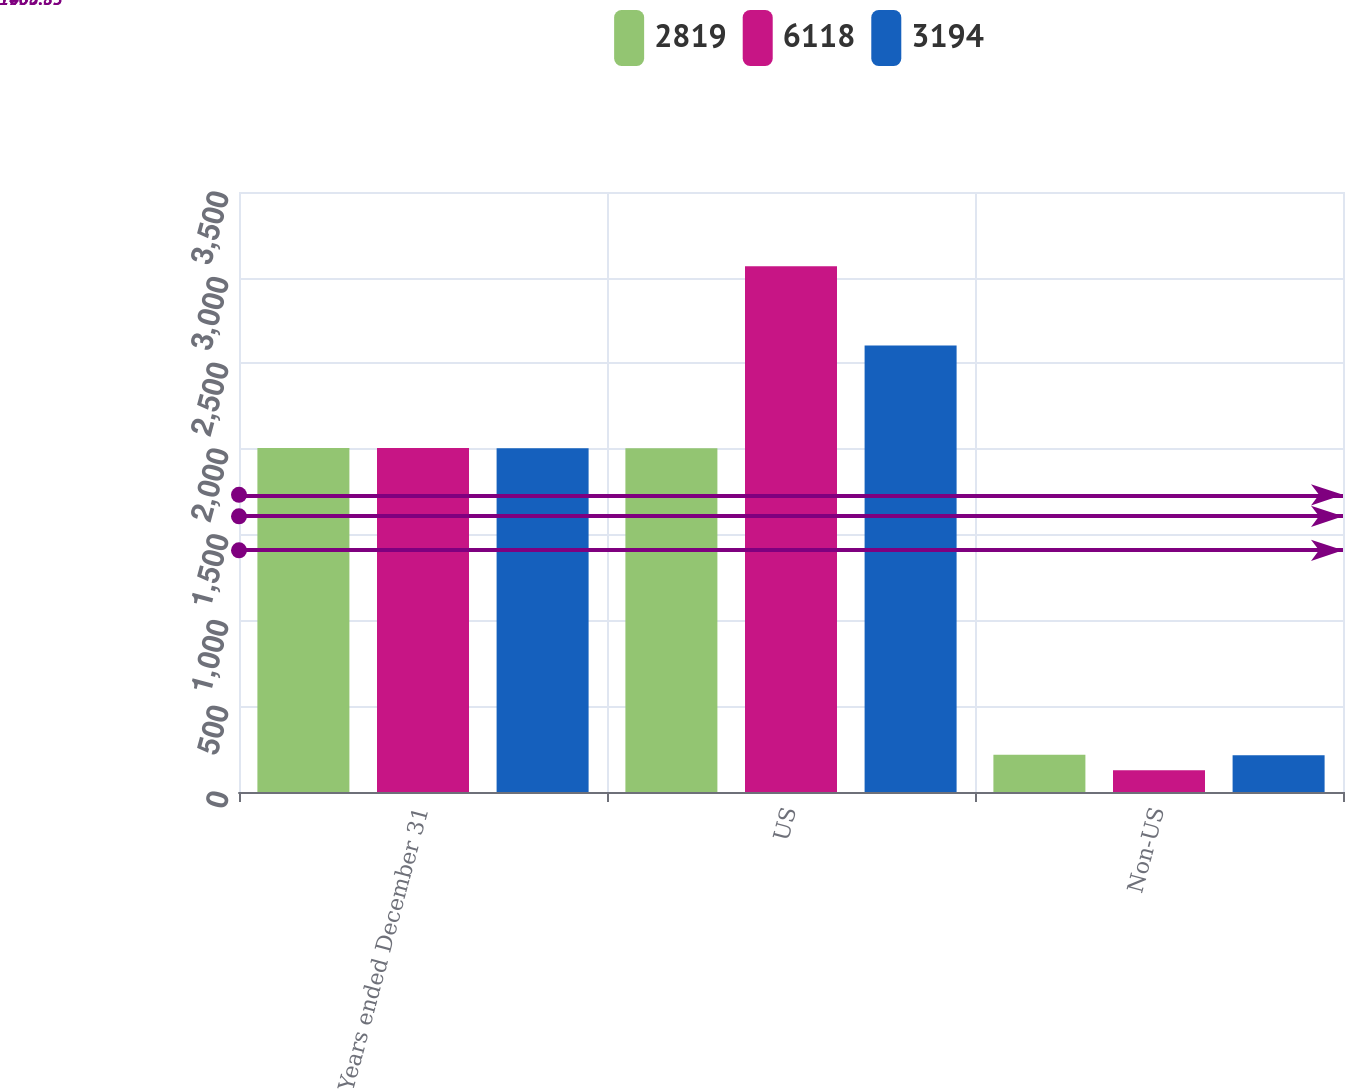Convert chart. <chart><loc_0><loc_0><loc_500><loc_500><stacked_bar_chart><ecel><fcel>Years ended December 31<fcel>US<fcel>Non-US<nl><fcel>2819<fcel>2007<fcel>2005.5<fcel>217<nl><fcel>6118<fcel>2006<fcel>3067<fcel>127<nl><fcel>3194<fcel>2005<fcel>2605<fcel>214<nl></chart> 